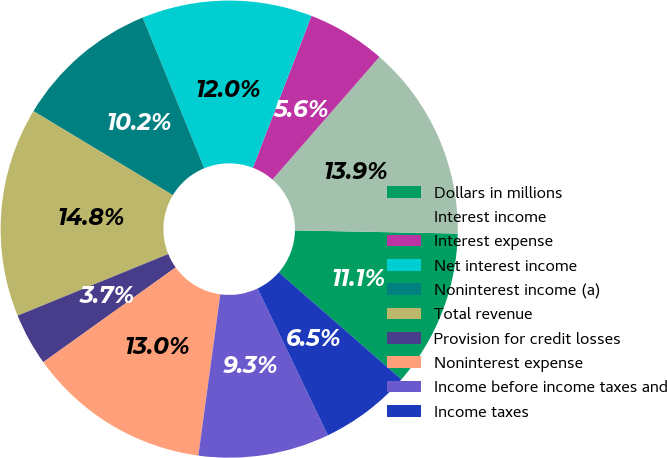Convert chart to OTSL. <chart><loc_0><loc_0><loc_500><loc_500><pie_chart><fcel>Dollars in millions<fcel>Interest income<fcel>Interest expense<fcel>Net interest income<fcel>Noninterest income (a)<fcel>Total revenue<fcel>Provision for credit losses<fcel>Noninterest expense<fcel>Income before income taxes and<fcel>Income taxes<nl><fcel>11.11%<fcel>13.89%<fcel>5.56%<fcel>12.04%<fcel>10.19%<fcel>14.81%<fcel>3.71%<fcel>12.96%<fcel>9.26%<fcel>6.48%<nl></chart> 